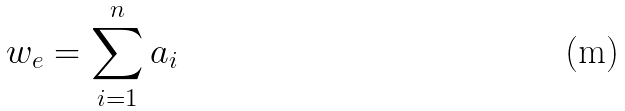Convert formula to latex. <formula><loc_0><loc_0><loc_500><loc_500>w _ { e } = \sum _ { i = 1 } ^ { n } a _ { i }</formula> 